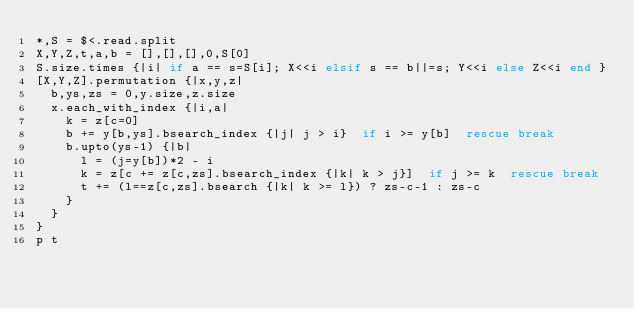Convert code to text. <code><loc_0><loc_0><loc_500><loc_500><_Ruby_>*,S = $<.read.split
X,Y,Z,t,a,b = [],[],[],0,S[0]
S.size.times {|i| if a == s=S[i]; X<<i elsif s == b||=s; Y<<i else Z<<i end }
[X,Y,Z].permutation {|x,y,z|
  b,ys,zs = 0,y.size,z.size
  x.each_with_index {|i,a|
    k = z[c=0]
    b += y[b,ys].bsearch_index {|j| j > i}  if i >= y[b]  rescue break
    b.upto(ys-1) {|b|
      l = (j=y[b])*2 - i
      k = z[c += z[c,zs].bsearch_index {|k| k > j}]  if j >= k  rescue break
      t += (l==z[c,zs].bsearch {|k| k >= l}) ? zs-c-1 : zs-c
    }
  }
}
p t</code> 